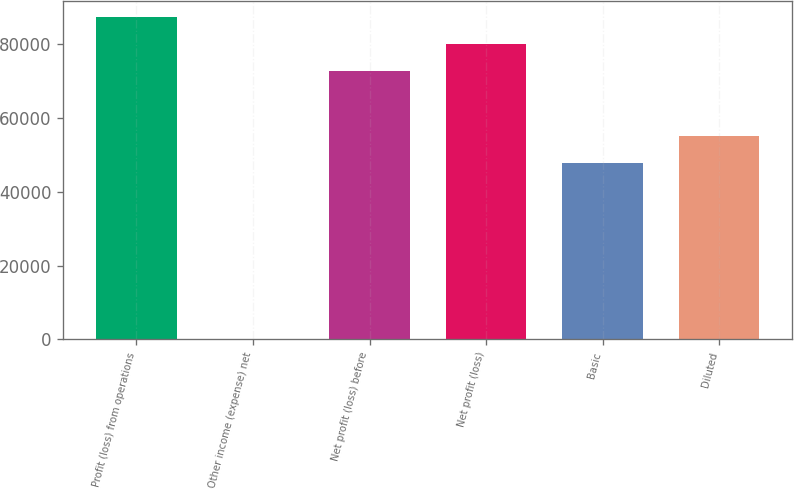<chart> <loc_0><loc_0><loc_500><loc_500><bar_chart><fcel>Profit (loss) from operations<fcel>Other income (expense) net<fcel>Net profit (loss) before<fcel>Net profit (loss)<fcel>Basic<fcel>Diluted<nl><fcel>87382.8<fcel>116<fcel>72819<fcel>80100.9<fcel>47878<fcel>55159.9<nl></chart> 